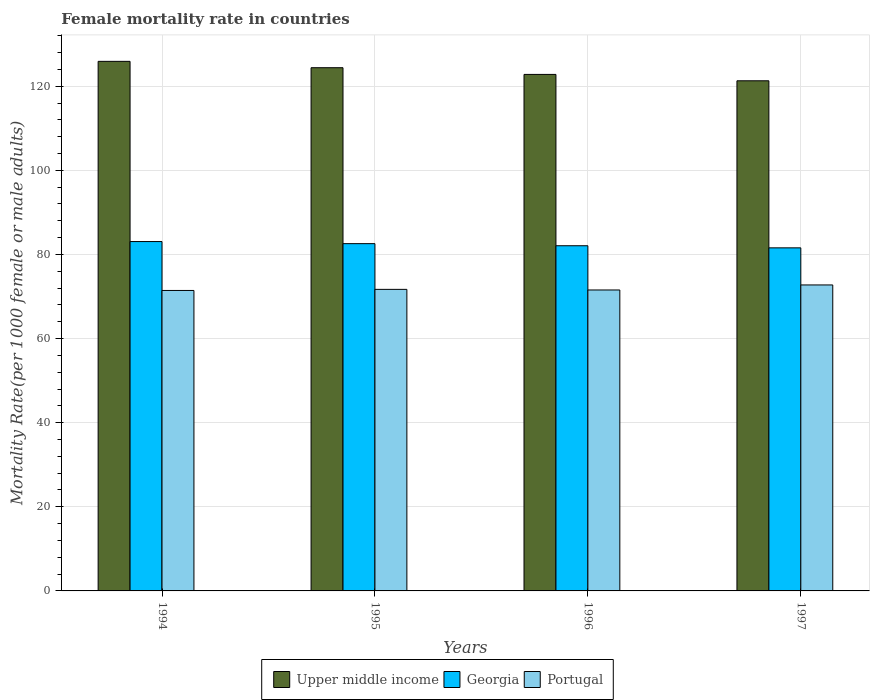Are the number of bars per tick equal to the number of legend labels?
Your answer should be very brief. Yes. Are the number of bars on each tick of the X-axis equal?
Your response must be concise. Yes. In how many cases, is the number of bars for a given year not equal to the number of legend labels?
Your answer should be compact. 0. What is the female mortality rate in Portugal in 1995?
Keep it short and to the point. 71.69. Across all years, what is the maximum female mortality rate in Georgia?
Offer a very short reply. 83.06. Across all years, what is the minimum female mortality rate in Portugal?
Offer a terse response. 71.43. In which year was the female mortality rate in Upper middle income minimum?
Offer a very short reply. 1997. What is the total female mortality rate in Upper middle income in the graph?
Keep it short and to the point. 494.38. What is the difference between the female mortality rate in Georgia in 1996 and that in 1997?
Make the answer very short. 0.5. What is the difference between the female mortality rate in Portugal in 1994 and the female mortality rate in Georgia in 1995?
Give a very brief answer. -11.13. What is the average female mortality rate in Portugal per year?
Provide a short and direct response. 71.85. In the year 1996, what is the difference between the female mortality rate in Georgia and female mortality rate in Upper middle income?
Ensure brevity in your answer.  -40.73. In how many years, is the female mortality rate in Portugal greater than 32?
Your response must be concise. 4. What is the ratio of the female mortality rate in Georgia in 1995 to that in 1996?
Provide a succinct answer. 1.01. Is the female mortality rate in Georgia in 1994 less than that in 1996?
Your answer should be very brief. No. Is the difference between the female mortality rate in Georgia in 1995 and 1997 greater than the difference between the female mortality rate in Upper middle income in 1995 and 1997?
Provide a short and direct response. No. What is the difference between the highest and the second highest female mortality rate in Portugal?
Provide a short and direct response. 1.05. What is the difference between the highest and the lowest female mortality rate in Upper middle income?
Make the answer very short. 4.62. Is the sum of the female mortality rate in Upper middle income in 1994 and 1997 greater than the maximum female mortality rate in Georgia across all years?
Provide a short and direct response. Yes. What does the 1st bar from the left in 1994 represents?
Provide a short and direct response. Upper middle income. What does the 1st bar from the right in 1997 represents?
Ensure brevity in your answer.  Portugal. Is it the case that in every year, the sum of the female mortality rate in Portugal and female mortality rate in Upper middle income is greater than the female mortality rate in Georgia?
Your response must be concise. Yes. How many bars are there?
Give a very brief answer. 12. How many years are there in the graph?
Offer a terse response. 4. What is the difference between two consecutive major ticks on the Y-axis?
Provide a succinct answer. 20. Are the values on the major ticks of Y-axis written in scientific E-notation?
Your answer should be compact. No. Does the graph contain any zero values?
Your answer should be compact. No. Does the graph contain grids?
Your response must be concise. Yes. Where does the legend appear in the graph?
Ensure brevity in your answer.  Bottom center. What is the title of the graph?
Keep it short and to the point. Female mortality rate in countries. What is the label or title of the X-axis?
Your answer should be compact. Years. What is the label or title of the Y-axis?
Provide a succinct answer. Mortality Rate(per 1000 female or male adults). What is the Mortality Rate(per 1000 female or male adults) of Upper middle income in 1994?
Offer a terse response. 125.9. What is the Mortality Rate(per 1000 female or male adults) of Georgia in 1994?
Offer a very short reply. 83.06. What is the Mortality Rate(per 1000 female or male adults) of Portugal in 1994?
Provide a short and direct response. 71.43. What is the Mortality Rate(per 1000 female or male adults) in Upper middle income in 1995?
Make the answer very short. 124.39. What is the Mortality Rate(per 1000 female or male adults) in Georgia in 1995?
Keep it short and to the point. 82.56. What is the Mortality Rate(per 1000 female or male adults) in Portugal in 1995?
Provide a short and direct response. 71.69. What is the Mortality Rate(per 1000 female or male adults) of Upper middle income in 1996?
Keep it short and to the point. 122.8. What is the Mortality Rate(per 1000 female or male adults) of Georgia in 1996?
Your response must be concise. 82.06. What is the Mortality Rate(per 1000 female or male adults) in Portugal in 1996?
Give a very brief answer. 71.55. What is the Mortality Rate(per 1000 female or male adults) of Upper middle income in 1997?
Ensure brevity in your answer.  121.28. What is the Mortality Rate(per 1000 female or male adults) of Georgia in 1997?
Your answer should be very brief. 81.56. What is the Mortality Rate(per 1000 female or male adults) in Portugal in 1997?
Make the answer very short. 72.74. Across all years, what is the maximum Mortality Rate(per 1000 female or male adults) in Upper middle income?
Keep it short and to the point. 125.9. Across all years, what is the maximum Mortality Rate(per 1000 female or male adults) in Georgia?
Ensure brevity in your answer.  83.06. Across all years, what is the maximum Mortality Rate(per 1000 female or male adults) in Portugal?
Give a very brief answer. 72.74. Across all years, what is the minimum Mortality Rate(per 1000 female or male adults) of Upper middle income?
Offer a terse response. 121.28. Across all years, what is the minimum Mortality Rate(per 1000 female or male adults) of Georgia?
Provide a short and direct response. 81.56. Across all years, what is the minimum Mortality Rate(per 1000 female or male adults) of Portugal?
Your response must be concise. 71.43. What is the total Mortality Rate(per 1000 female or male adults) of Upper middle income in the graph?
Make the answer very short. 494.38. What is the total Mortality Rate(per 1000 female or male adults) in Georgia in the graph?
Give a very brief answer. 329.25. What is the total Mortality Rate(per 1000 female or male adults) in Portugal in the graph?
Make the answer very short. 287.42. What is the difference between the Mortality Rate(per 1000 female or male adults) in Upper middle income in 1994 and that in 1995?
Offer a terse response. 1.51. What is the difference between the Mortality Rate(per 1000 female or male adults) in Georgia in 1994 and that in 1995?
Your answer should be compact. 0.5. What is the difference between the Mortality Rate(per 1000 female or male adults) of Portugal in 1994 and that in 1995?
Your answer should be compact. -0.26. What is the difference between the Mortality Rate(per 1000 female or male adults) of Upper middle income in 1994 and that in 1996?
Offer a very short reply. 3.11. What is the difference between the Mortality Rate(per 1000 female or male adults) in Portugal in 1994 and that in 1996?
Provide a short and direct response. -0.12. What is the difference between the Mortality Rate(per 1000 female or male adults) of Upper middle income in 1994 and that in 1997?
Give a very brief answer. 4.62. What is the difference between the Mortality Rate(per 1000 female or male adults) of Georgia in 1994 and that in 1997?
Your answer should be very brief. 1.5. What is the difference between the Mortality Rate(per 1000 female or male adults) in Portugal in 1994 and that in 1997?
Make the answer very short. -1.31. What is the difference between the Mortality Rate(per 1000 female or male adults) of Upper middle income in 1995 and that in 1996?
Your answer should be very brief. 1.6. What is the difference between the Mortality Rate(per 1000 female or male adults) of Georgia in 1995 and that in 1996?
Provide a short and direct response. 0.5. What is the difference between the Mortality Rate(per 1000 female or male adults) in Portugal in 1995 and that in 1996?
Provide a succinct answer. 0.15. What is the difference between the Mortality Rate(per 1000 female or male adults) in Upper middle income in 1995 and that in 1997?
Offer a very short reply. 3.11. What is the difference between the Mortality Rate(per 1000 female or male adults) of Portugal in 1995 and that in 1997?
Offer a very short reply. -1.05. What is the difference between the Mortality Rate(per 1000 female or male adults) in Upper middle income in 1996 and that in 1997?
Provide a succinct answer. 1.51. What is the difference between the Mortality Rate(per 1000 female or male adults) of Georgia in 1996 and that in 1997?
Keep it short and to the point. 0.5. What is the difference between the Mortality Rate(per 1000 female or male adults) in Portugal in 1996 and that in 1997?
Your response must be concise. -1.2. What is the difference between the Mortality Rate(per 1000 female or male adults) of Upper middle income in 1994 and the Mortality Rate(per 1000 female or male adults) of Georgia in 1995?
Your answer should be very brief. 43.34. What is the difference between the Mortality Rate(per 1000 female or male adults) in Upper middle income in 1994 and the Mortality Rate(per 1000 female or male adults) in Portugal in 1995?
Your answer should be very brief. 54.21. What is the difference between the Mortality Rate(per 1000 female or male adults) of Georgia in 1994 and the Mortality Rate(per 1000 female or male adults) of Portugal in 1995?
Provide a short and direct response. 11.37. What is the difference between the Mortality Rate(per 1000 female or male adults) in Upper middle income in 1994 and the Mortality Rate(per 1000 female or male adults) in Georgia in 1996?
Give a very brief answer. 43.84. What is the difference between the Mortality Rate(per 1000 female or male adults) of Upper middle income in 1994 and the Mortality Rate(per 1000 female or male adults) of Portugal in 1996?
Give a very brief answer. 54.36. What is the difference between the Mortality Rate(per 1000 female or male adults) in Georgia in 1994 and the Mortality Rate(per 1000 female or male adults) in Portugal in 1996?
Offer a very short reply. 11.51. What is the difference between the Mortality Rate(per 1000 female or male adults) in Upper middle income in 1994 and the Mortality Rate(per 1000 female or male adults) in Georgia in 1997?
Your answer should be compact. 44.34. What is the difference between the Mortality Rate(per 1000 female or male adults) in Upper middle income in 1994 and the Mortality Rate(per 1000 female or male adults) in Portugal in 1997?
Provide a short and direct response. 53.16. What is the difference between the Mortality Rate(per 1000 female or male adults) of Georgia in 1994 and the Mortality Rate(per 1000 female or male adults) of Portugal in 1997?
Your answer should be compact. 10.32. What is the difference between the Mortality Rate(per 1000 female or male adults) in Upper middle income in 1995 and the Mortality Rate(per 1000 female or male adults) in Georgia in 1996?
Give a very brief answer. 42.33. What is the difference between the Mortality Rate(per 1000 female or male adults) of Upper middle income in 1995 and the Mortality Rate(per 1000 female or male adults) of Portugal in 1996?
Offer a terse response. 52.85. What is the difference between the Mortality Rate(per 1000 female or male adults) of Georgia in 1995 and the Mortality Rate(per 1000 female or male adults) of Portugal in 1996?
Give a very brief answer. 11.02. What is the difference between the Mortality Rate(per 1000 female or male adults) of Upper middle income in 1995 and the Mortality Rate(per 1000 female or male adults) of Georgia in 1997?
Provide a short and direct response. 42.83. What is the difference between the Mortality Rate(per 1000 female or male adults) in Upper middle income in 1995 and the Mortality Rate(per 1000 female or male adults) in Portugal in 1997?
Give a very brief answer. 51.65. What is the difference between the Mortality Rate(per 1000 female or male adults) in Georgia in 1995 and the Mortality Rate(per 1000 female or male adults) in Portugal in 1997?
Keep it short and to the point. 9.82. What is the difference between the Mortality Rate(per 1000 female or male adults) in Upper middle income in 1996 and the Mortality Rate(per 1000 female or male adults) in Georgia in 1997?
Keep it short and to the point. 41.23. What is the difference between the Mortality Rate(per 1000 female or male adults) in Upper middle income in 1996 and the Mortality Rate(per 1000 female or male adults) in Portugal in 1997?
Your answer should be compact. 50.05. What is the difference between the Mortality Rate(per 1000 female or male adults) of Georgia in 1996 and the Mortality Rate(per 1000 female or male adults) of Portugal in 1997?
Provide a short and direct response. 9.32. What is the average Mortality Rate(per 1000 female or male adults) of Upper middle income per year?
Provide a succinct answer. 123.59. What is the average Mortality Rate(per 1000 female or male adults) in Georgia per year?
Provide a succinct answer. 82.31. What is the average Mortality Rate(per 1000 female or male adults) of Portugal per year?
Your answer should be compact. 71.85. In the year 1994, what is the difference between the Mortality Rate(per 1000 female or male adults) in Upper middle income and Mortality Rate(per 1000 female or male adults) in Georgia?
Make the answer very short. 42.84. In the year 1994, what is the difference between the Mortality Rate(per 1000 female or male adults) in Upper middle income and Mortality Rate(per 1000 female or male adults) in Portugal?
Your response must be concise. 54.47. In the year 1994, what is the difference between the Mortality Rate(per 1000 female or male adults) in Georgia and Mortality Rate(per 1000 female or male adults) in Portugal?
Ensure brevity in your answer.  11.63. In the year 1995, what is the difference between the Mortality Rate(per 1000 female or male adults) in Upper middle income and Mortality Rate(per 1000 female or male adults) in Georgia?
Keep it short and to the point. 41.83. In the year 1995, what is the difference between the Mortality Rate(per 1000 female or male adults) in Upper middle income and Mortality Rate(per 1000 female or male adults) in Portugal?
Keep it short and to the point. 52.7. In the year 1995, what is the difference between the Mortality Rate(per 1000 female or male adults) in Georgia and Mortality Rate(per 1000 female or male adults) in Portugal?
Offer a very short reply. 10.87. In the year 1996, what is the difference between the Mortality Rate(per 1000 female or male adults) of Upper middle income and Mortality Rate(per 1000 female or male adults) of Georgia?
Your answer should be compact. 40.73. In the year 1996, what is the difference between the Mortality Rate(per 1000 female or male adults) in Upper middle income and Mortality Rate(per 1000 female or male adults) in Portugal?
Ensure brevity in your answer.  51.25. In the year 1996, what is the difference between the Mortality Rate(per 1000 female or male adults) in Georgia and Mortality Rate(per 1000 female or male adults) in Portugal?
Make the answer very short. 10.52. In the year 1997, what is the difference between the Mortality Rate(per 1000 female or male adults) of Upper middle income and Mortality Rate(per 1000 female or male adults) of Georgia?
Provide a short and direct response. 39.72. In the year 1997, what is the difference between the Mortality Rate(per 1000 female or male adults) of Upper middle income and Mortality Rate(per 1000 female or male adults) of Portugal?
Keep it short and to the point. 48.54. In the year 1997, what is the difference between the Mortality Rate(per 1000 female or male adults) of Georgia and Mortality Rate(per 1000 female or male adults) of Portugal?
Your answer should be compact. 8.82. What is the ratio of the Mortality Rate(per 1000 female or male adults) of Upper middle income in 1994 to that in 1995?
Give a very brief answer. 1.01. What is the ratio of the Mortality Rate(per 1000 female or male adults) in Upper middle income in 1994 to that in 1996?
Offer a terse response. 1.03. What is the ratio of the Mortality Rate(per 1000 female or male adults) in Georgia in 1994 to that in 1996?
Offer a terse response. 1.01. What is the ratio of the Mortality Rate(per 1000 female or male adults) of Upper middle income in 1994 to that in 1997?
Your response must be concise. 1.04. What is the ratio of the Mortality Rate(per 1000 female or male adults) in Georgia in 1994 to that in 1997?
Your response must be concise. 1.02. What is the ratio of the Mortality Rate(per 1000 female or male adults) of Upper middle income in 1995 to that in 1996?
Provide a succinct answer. 1.01. What is the ratio of the Mortality Rate(per 1000 female or male adults) of Upper middle income in 1995 to that in 1997?
Make the answer very short. 1.03. What is the ratio of the Mortality Rate(per 1000 female or male adults) of Georgia in 1995 to that in 1997?
Offer a very short reply. 1.01. What is the ratio of the Mortality Rate(per 1000 female or male adults) of Portugal in 1995 to that in 1997?
Offer a very short reply. 0.99. What is the ratio of the Mortality Rate(per 1000 female or male adults) in Upper middle income in 1996 to that in 1997?
Your answer should be compact. 1.01. What is the ratio of the Mortality Rate(per 1000 female or male adults) in Georgia in 1996 to that in 1997?
Offer a terse response. 1.01. What is the ratio of the Mortality Rate(per 1000 female or male adults) in Portugal in 1996 to that in 1997?
Offer a terse response. 0.98. What is the difference between the highest and the second highest Mortality Rate(per 1000 female or male adults) of Upper middle income?
Provide a short and direct response. 1.51. What is the difference between the highest and the second highest Mortality Rate(per 1000 female or male adults) of Georgia?
Provide a succinct answer. 0.5. What is the difference between the highest and the second highest Mortality Rate(per 1000 female or male adults) of Portugal?
Offer a very short reply. 1.05. What is the difference between the highest and the lowest Mortality Rate(per 1000 female or male adults) of Upper middle income?
Keep it short and to the point. 4.62. What is the difference between the highest and the lowest Mortality Rate(per 1000 female or male adults) in Georgia?
Your response must be concise. 1.5. What is the difference between the highest and the lowest Mortality Rate(per 1000 female or male adults) of Portugal?
Provide a succinct answer. 1.31. 